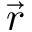<formula> <loc_0><loc_0><loc_500><loc_500>\vec { r }</formula> 